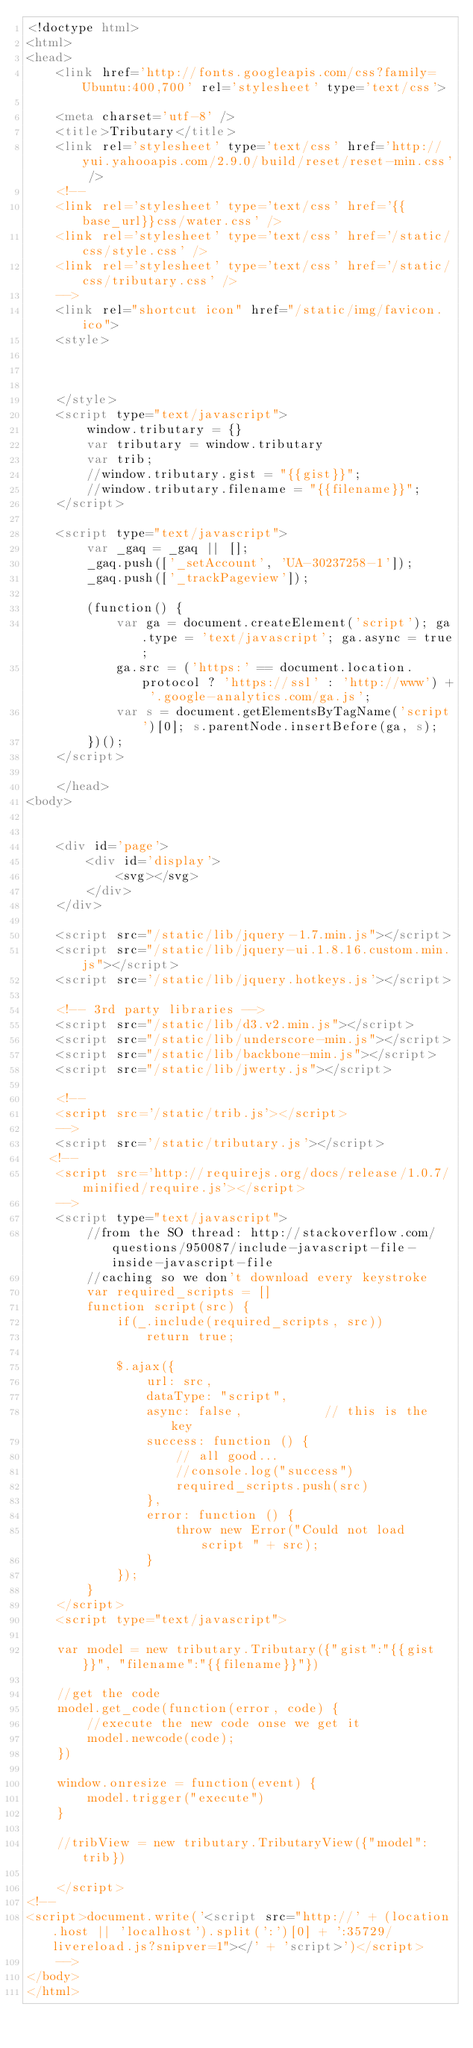<code> <loc_0><loc_0><loc_500><loc_500><_HTML_><!doctype html>
<html>
<head>
    <link href='http://fonts.googleapis.com/css?family=Ubuntu:400,700' rel='stylesheet' type='text/css'>
    
    <meta charset='utf-8' />
    <title>Tributary</title>
    <link rel='stylesheet' type='text/css' href='http://yui.yahooapis.com/2.9.0/build/reset/reset-min.css' />
    <!--
    <link rel='stylesheet' type='text/css' href='{{base_url}}css/water.css' />
    <link rel='stylesheet' type='text/css' href='/static/css/style.css' />
    <link rel='stylesheet' type='text/css' href='/static/css/tributary.css' />
    -->
    <link rel="shortcut icon" href="/static/img/favicon.ico">
    <style>

    

    </style>
    <script type="text/javascript">
        window.tributary = {}
        var tributary = window.tributary
        var trib;
        //window.tributary.gist = "{{gist}}";
        //window.tributary.filename = "{{filename}}";
    </script>

    <script type="text/javascript">
        var _gaq = _gaq || [];
        _gaq.push(['_setAccount', 'UA-30237258-1']);
        _gaq.push(['_trackPageview']);

        (function() {
            var ga = document.createElement('script'); ga.type = 'text/javascript'; ga.async = true;
            ga.src = ('https:' == document.location.protocol ? 'https://ssl' : 'http://www') + '.google-analytics.com/ga.js';
            var s = document.getElementsByTagName('script')[0]; s.parentNode.insertBefore(ga, s);
        })();
    </script>

    </head>
<body>

   
    <div id='page'>
        <div id='display'>
            <svg></svg>
        </div>
    </div>

    <script src="/static/lib/jquery-1.7.min.js"></script>
    <script src="/static/lib/jquery-ui.1.8.16.custom.min.js"></script>
    <script src='/static/lib/jquery.hotkeys.js'></script>

    <!-- 3rd party libraries -->
    <script src="/static/lib/d3.v2.min.js"></script>
    <script src="/static/lib/underscore-min.js"></script>
    <script src="/static/lib/backbone-min.js"></script>
    <script src="/static/lib/jwerty.js"></script>

    <!--
    <script src='/static/trib.js'></script>
    -->
    <script src='/static/tributary.js'></script>
   <!--
    <script src='http://requirejs.org/docs/release/1.0.7/minified/require.js'></script>
    -->
    <script type="text/javascript">
        //from the SO thread: http://stackoverflow.com/questions/950087/include-javascript-file-inside-javascript-file
        //caching so we don't download every keystroke
        var required_scripts = []
        function script(src) {
            if(_.include(required_scripts, src))
                return true;

            $.ajax({
                url: src,
                dataType: "script",
                async: false,           // this is the key
                success: function () {
                    // all good...
                    //console.log("success")
                    required_scripts.push(src)
                },
                error: function () {
                    throw new Error("Could not load script " + src);
                }
            });
        }
    </script>
    <script type="text/javascript">

    var model = new tributary.Tributary({"gist":"{{gist}}", "filename":"{{filename}}"})

    //get the code
    model.get_code(function(error, code) {
        //execute the new code onse we get it
        model.newcode(code);         
    })

    window.onresize = function(event) {
        model.trigger("execute")
    }

    //tribView = new tributary.TributaryView({"model":trib})

    </script>
<!--
<script>document.write('<script src="http://' + (location.host || 'localhost').split(':')[0] + ':35729/livereload.js?snipver=1"></' + 'script>')</script>
    -->
</body>
</html>
</code> 